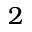Convert formula to latex. <formula><loc_0><loc_0><loc_500><loc_500>2</formula> 